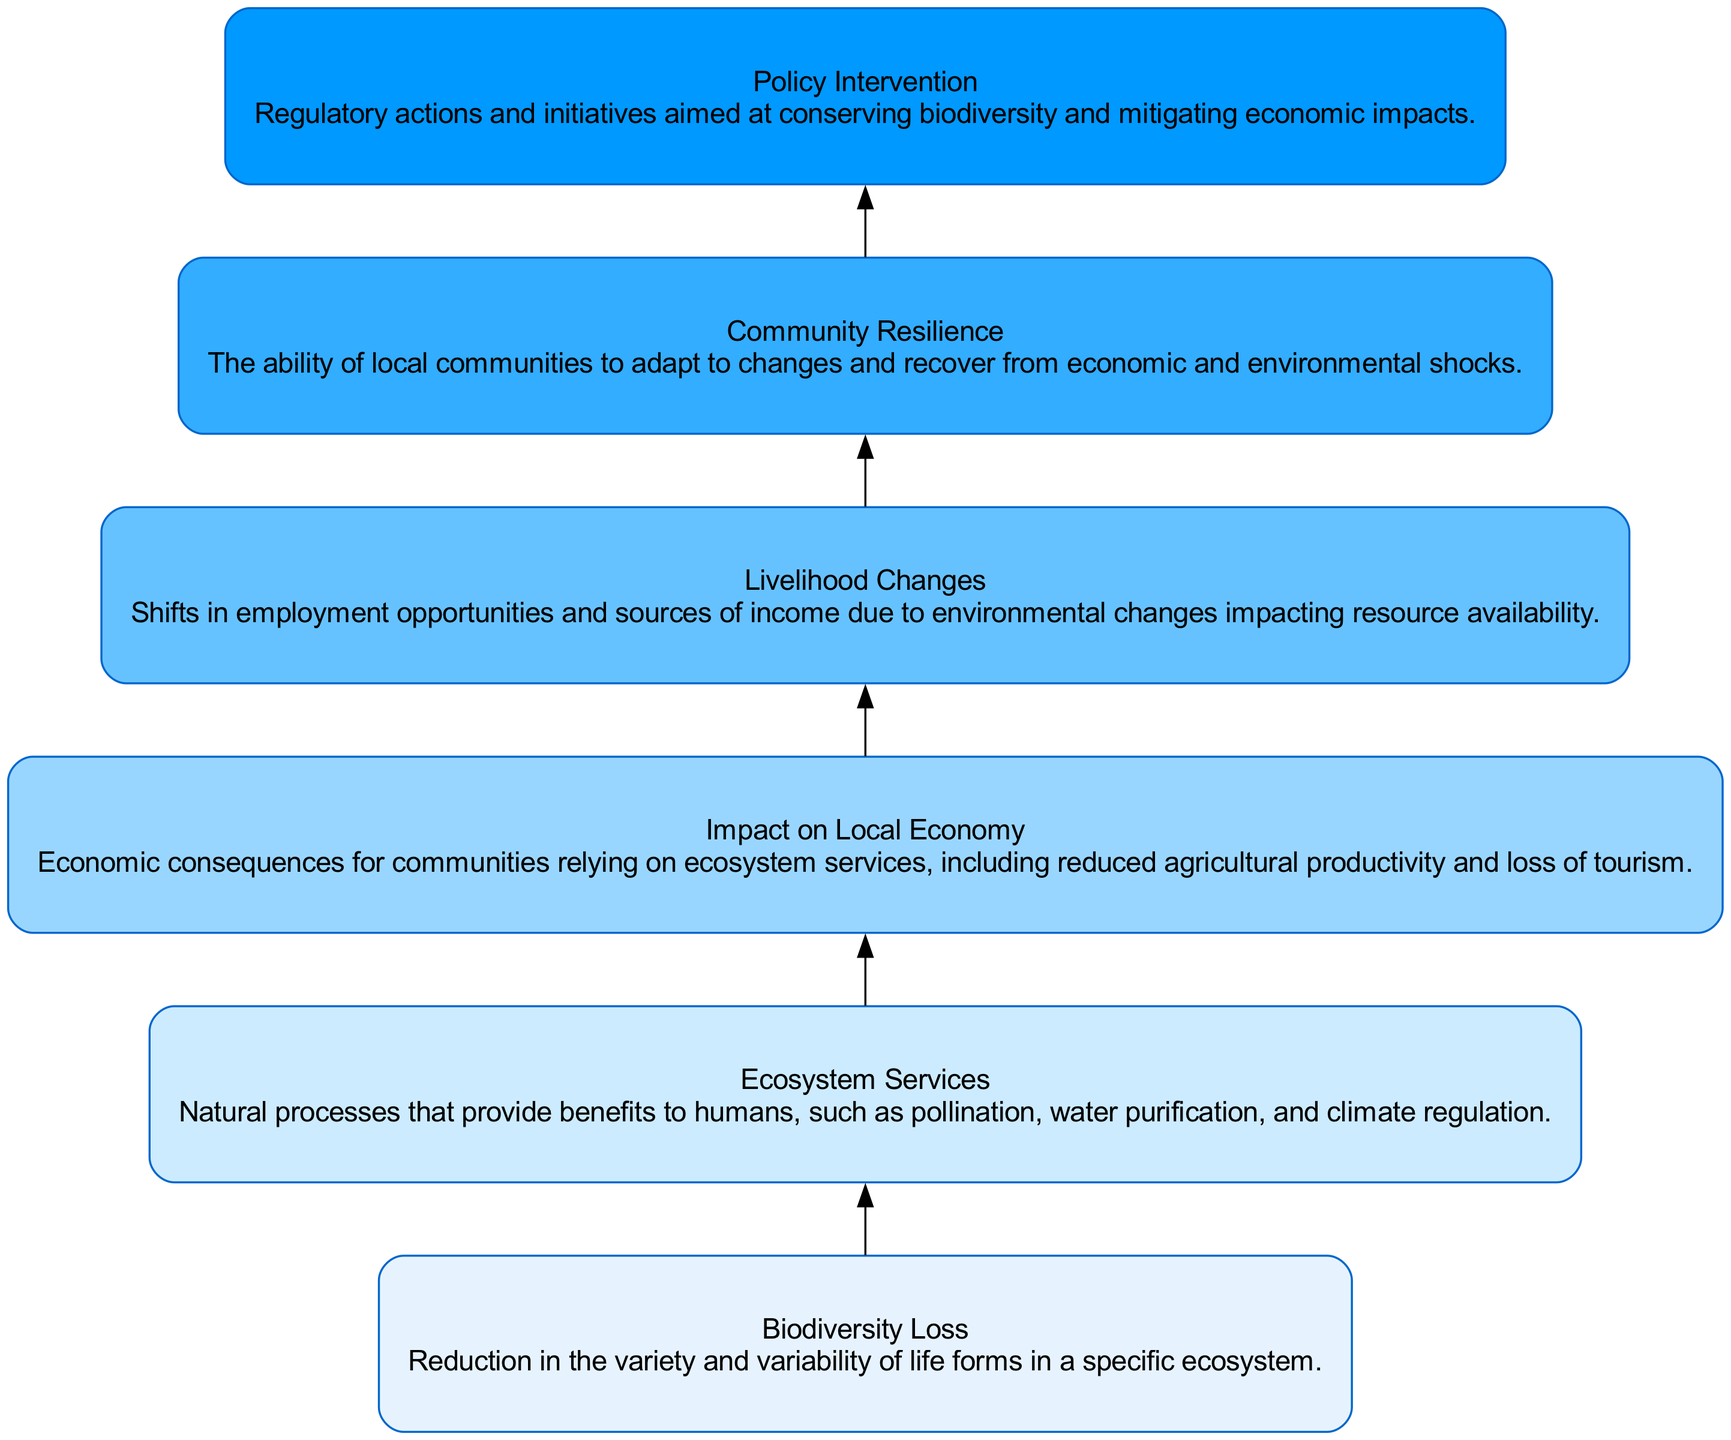What is the first node in the flow chart? The first node in the diagram is labeled "Biodiversity Loss," indicating it is the starting point of the flow chart depicting the assessment of biodiversity loss on local economies.
Answer: Biodiversity Loss How many total nodes are in the diagram? Counting the nodes listed in the data structure, we find there are six nodes: Biodiversity Loss, Ecosystem Services, Impact on Local Economy, Livelihood Changes, Community Resilience, and Policy Intervention.
Answer: 6 What is the last node in the flow chart? The last node in the diagram is "Policy Intervention," which is the final step in the flow of information regarding the impact of biodiversity loss on local economies.
Answer: Policy Intervention Which nodes are directly connected to "Ecosystem Services"? The node directly connected to "Ecosystem Services" is "Impact on Local Economy," showing a direct impact from the services provided by ecosystems.
Answer: Impact on Local Economy What is the relationship between "Livelihood Changes" and "Community Resilience"? "Livelihood Changes" directly influences "Community Resilience," suggesting that the shifts in employment and income sources will affect how well a community can adapt and recover.
Answer: Livelihood Changes → Community Resilience What are the effects of "Biodiversity Loss" as per the diagram? The effects of "Biodiversity Loss" lead to "Ecosystem Services," which then affects "Impact on Local Economy," indicating a chain reaction starting from biodiversity loss.
Answer: Ecosystem Services → Impact on Local Economy Which node illustrates the final outcome from the flow? The final outcome in the flow is represented by "Policy Intervention," which concludes the assessment by indicating a response to the issues caused by biodiversity loss.
Answer: Policy Intervention How many connections lead from "Local Economy Impact"? There is one connection leading from "Local Economy Impact," which goes to "Livelihood Changes," meaning it has a direct impact on changes in livelihoods.
Answer: 1 What does "Policy Intervention" represent in the context of the flow chart? "Policy Intervention" represents the regulatory actions and initiatives designed to address the impacts of biodiversity loss and to promote sustainability, completing the cycle of understanding and action.
Answer: Regulatory actions and initiatives to address impacts 